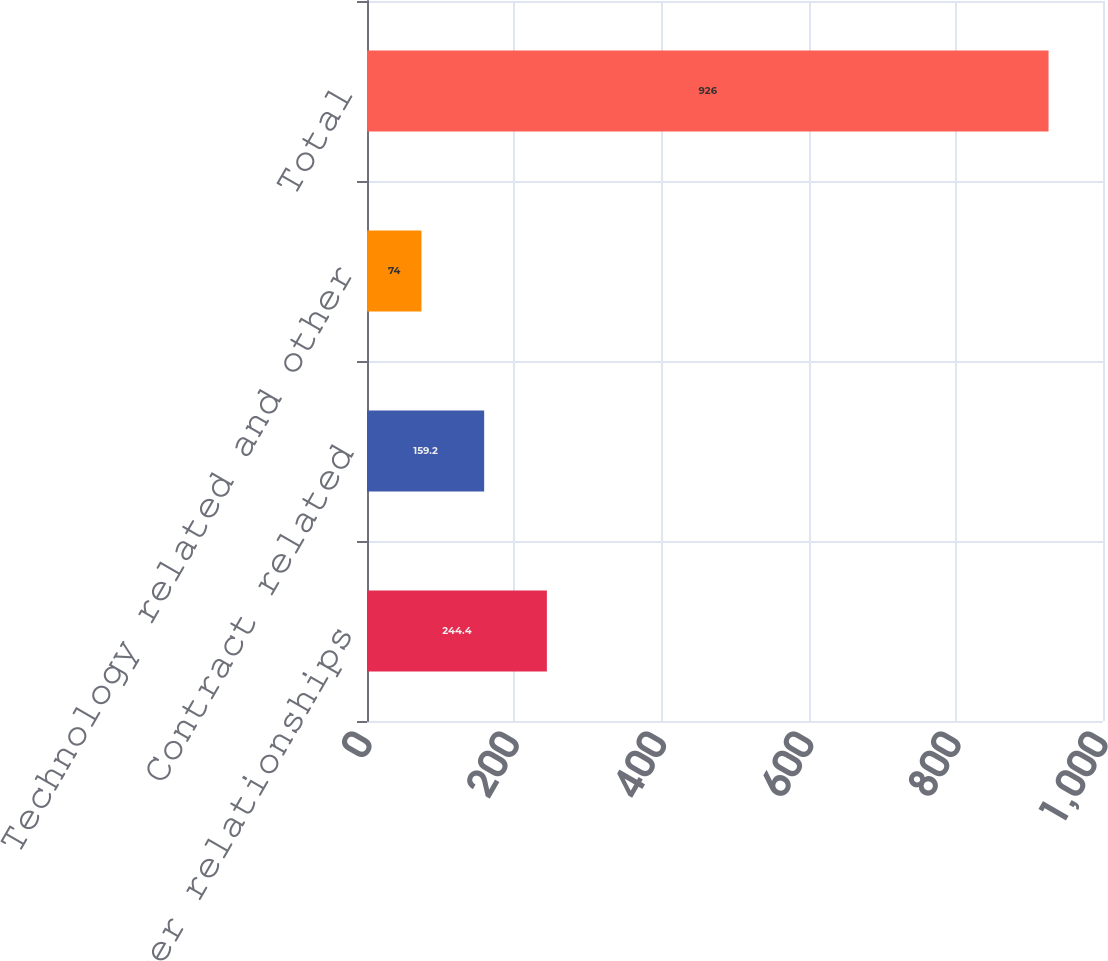Convert chart. <chart><loc_0><loc_0><loc_500><loc_500><bar_chart><fcel>Customer relationships<fcel>Contract related<fcel>Technology related and other<fcel>Total<nl><fcel>244.4<fcel>159.2<fcel>74<fcel>926<nl></chart> 